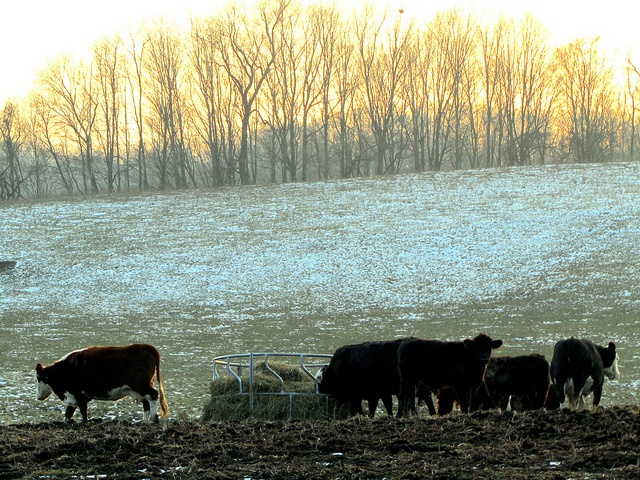Describe the objects in this image and their specific colors. I can see cow in white, black, gray, and darkgray tones, cow in white, black, gray, and maroon tones, cow in white, black, gray, darkgreen, and darkgray tones, cow in white, black, and gray tones, and cow in white, black, gray, and maroon tones in this image. 